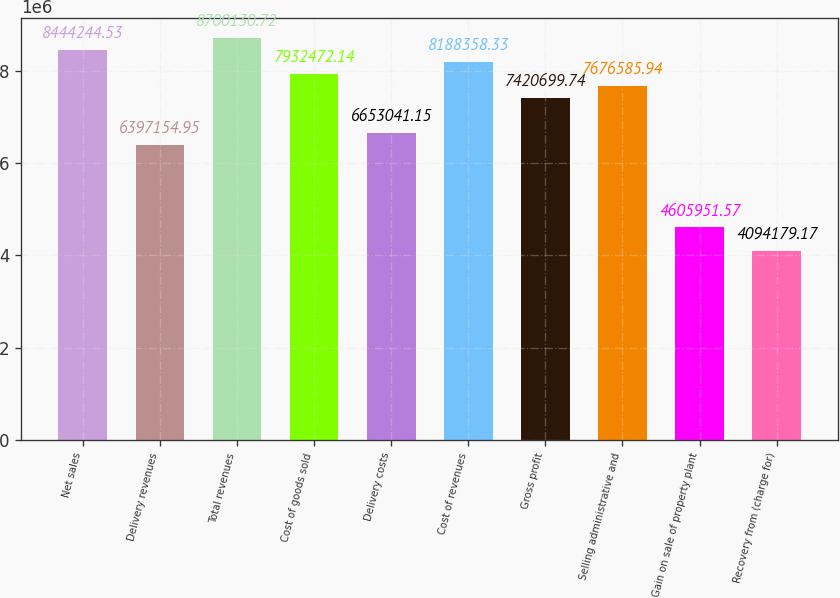Convert chart. <chart><loc_0><loc_0><loc_500><loc_500><bar_chart><fcel>Net sales<fcel>Delivery revenues<fcel>Total revenues<fcel>Cost of goods sold<fcel>Delivery costs<fcel>Cost of revenues<fcel>Gross profit<fcel>Selling administrative and<fcel>Gain on sale of property plant<fcel>Recovery from (charge for)<nl><fcel>8.44424e+06<fcel>6.39715e+06<fcel>8.70013e+06<fcel>7.93247e+06<fcel>6.65304e+06<fcel>8.18836e+06<fcel>7.4207e+06<fcel>7.67659e+06<fcel>4.60595e+06<fcel>4.09418e+06<nl></chart> 